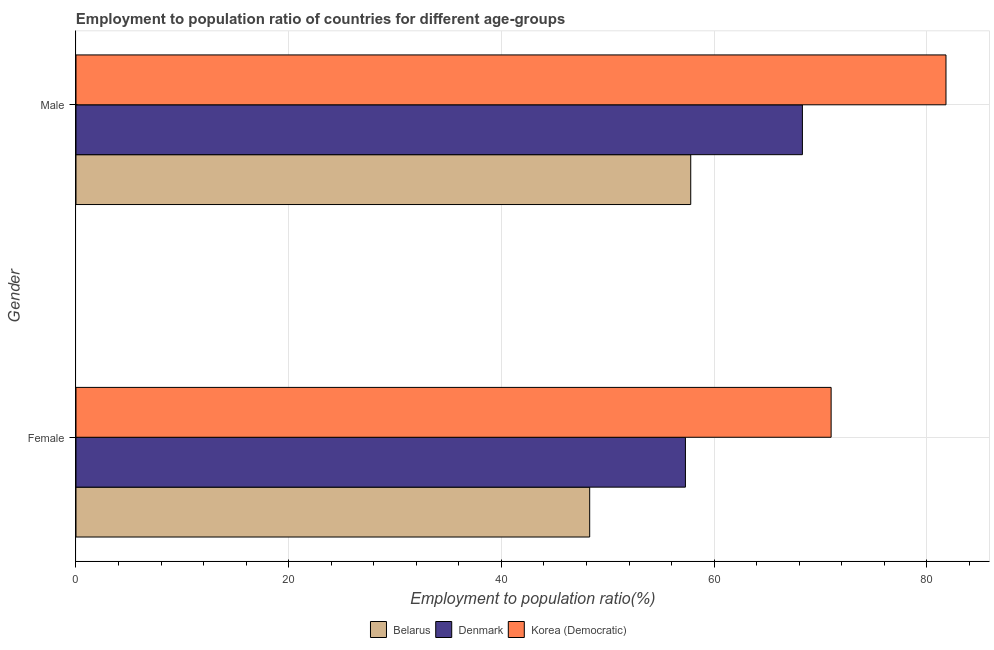How many groups of bars are there?
Offer a very short reply. 2. Are the number of bars on each tick of the Y-axis equal?
Give a very brief answer. Yes. What is the employment to population ratio(female) in Korea (Democratic)?
Offer a terse response. 71. Across all countries, what is the minimum employment to population ratio(female)?
Offer a very short reply. 48.3. In which country was the employment to population ratio(male) maximum?
Ensure brevity in your answer.  Korea (Democratic). In which country was the employment to population ratio(female) minimum?
Your answer should be very brief. Belarus. What is the total employment to population ratio(female) in the graph?
Keep it short and to the point. 176.6. What is the difference between the employment to population ratio(female) in Korea (Democratic) and that in Denmark?
Provide a succinct answer. 13.7. What is the difference between the employment to population ratio(female) in Korea (Democratic) and the employment to population ratio(male) in Denmark?
Offer a terse response. 2.7. What is the average employment to population ratio(female) per country?
Ensure brevity in your answer.  58.87. What is the difference between the employment to population ratio(male) and employment to population ratio(female) in Korea (Democratic)?
Make the answer very short. 10.8. In how many countries, is the employment to population ratio(male) greater than 72 %?
Provide a short and direct response. 1. What is the ratio of the employment to population ratio(female) in Korea (Democratic) to that in Belarus?
Provide a short and direct response. 1.47. Is the employment to population ratio(female) in Korea (Democratic) less than that in Denmark?
Provide a short and direct response. No. What does the 2nd bar from the top in Male represents?
Provide a short and direct response. Denmark. What does the 2nd bar from the bottom in Male represents?
Give a very brief answer. Denmark. How many bars are there?
Your answer should be very brief. 6. Are all the bars in the graph horizontal?
Make the answer very short. Yes. How many countries are there in the graph?
Ensure brevity in your answer.  3. Does the graph contain grids?
Provide a succinct answer. Yes. Where does the legend appear in the graph?
Provide a short and direct response. Bottom center. How are the legend labels stacked?
Offer a terse response. Horizontal. What is the title of the graph?
Ensure brevity in your answer.  Employment to population ratio of countries for different age-groups. What is the label or title of the X-axis?
Keep it short and to the point. Employment to population ratio(%). What is the Employment to population ratio(%) of Belarus in Female?
Make the answer very short. 48.3. What is the Employment to population ratio(%) of Denmark in Female?
Provide a succinct answer. 57.3. What is the Employment to population ratio(%) of Korea (Democratic) in Female?
Ensure brevity in your answer.  71. What is the Employment to population ratio(%) of Belarus in Male?
Make the answer very short. 57.8. What is the Employment to population ratio(%) of Denmark in Male?
Your answer should be compact. 68.3. What is the Employment to population ratio(%) in Korea (Democratic) in Male?
Keep it short and to the point. 81.8. Across all Gender, what is the maximum Employment to population ratio(%) in Belarus?
Provide a succinct answer. 57.8. Across all Gender, what is the maximum Employment to population ratio(%) of Denmark?
Offer a very short reply. 68.3. Across all Gender, what is the maximum Employment to population ratio(%) of Korea (Democratic)?
Provide a succinct answer. 81.8. Across all Gender, what is the minimum Employment to population ratio(%) of Belarus?
Ensure brevity in your answer.  48.3. Across all Gender, what is the minimum Employment to population ratio(%) in Denmark?
Provide a succinct answer. 57.3. What is the total Employment to population ratio(%) in Belarus in the graph?
Provide a succinct answer. 106.1. What is the total Employment to population ratio(%) of Denmark in the graph?
Make the answer very short. 125.6. What is the total Employment to population ratio(%) of Korea (Democratic) in the graph?
Provide a succinct answer. 152.8. What is the difference between the Employment to population ratio(%) in Belarus in Female and that in Male?
Your answer should be compact. -9.5. What is the difference between the Employment to population ratio(%) of Belarus in Female and the Employment to population ratio(%) of Denmark in Male?
Your response must be concise. -20. What is the difference between the Employment to population ratio(%) of Belarus in Female and the Employment to population ratio(%) of Korea (Democratic) in Male?
Offer a very short reply. -33.5. What is the difference between the Employment to population ratio(%) of Denmark in Female and the Employment to population ratio(%) of Korea (Democratic) in Male?
Give a very brief answer. -24.5. What is the average Employment to population ratio(%) in Belarus per Gender?
Your answer should be compact. 53.05. What is the average Employment to population ratio(%) of Denmark per Gender?
Give a very brief answer. 62.8. What is the average Employment to population ratio(%) in Korea (Democratic) per Gender?
Your response must be concise. 76.4. What is the difference between the Employment to population ratio(%) in Belarus and Employment to population ratio(%) in Korea (Democratic) in Female?
Provide a succinct answer. -22.7. What is the difference between the Employment to population ratio(%) in Denmark and Employment to population ratio(%) in Korea (Democratic) in Female?
Your response must be concise. -13.7. What is the difference between the Employment to population ratio(%) of Belarus and Employment to population ratio(%) of Denmark in Male?
Your answer should be very brief. -10.5. What is the difference between the Employment to population ratio(%) in Denmark and Employment to population ratio(%) in Korea (Democratic) in Male?
Your response must be concise. -13.5. What is the ratio of the Employment to population ratio(%) in Belarus in Female to that in Male?
Provide a succinct answer. 0.84. What is the ratio of the Employment to population ratio(%) in Denmark in Female to that in Male?
Ensure brevity in your answer.  0.84. What is the ratio of the Employment to population ratio(%) in Korea (Democratic) in Female to that in Male?
Ensure brevity in your answer.  0.87. What is the difference between the highest and the second highest Employment to population ratio(%) of Belarus?
Give a very brief answer. 9.5. What is the difference between the highest and the second highest Employment to population ratio(%) in Denmark?
Offer a terse response. 11. What is the difference between the highest and the lowest Employment to population ratio(%) in Denmark?
Provide a short and direct response. 11. 